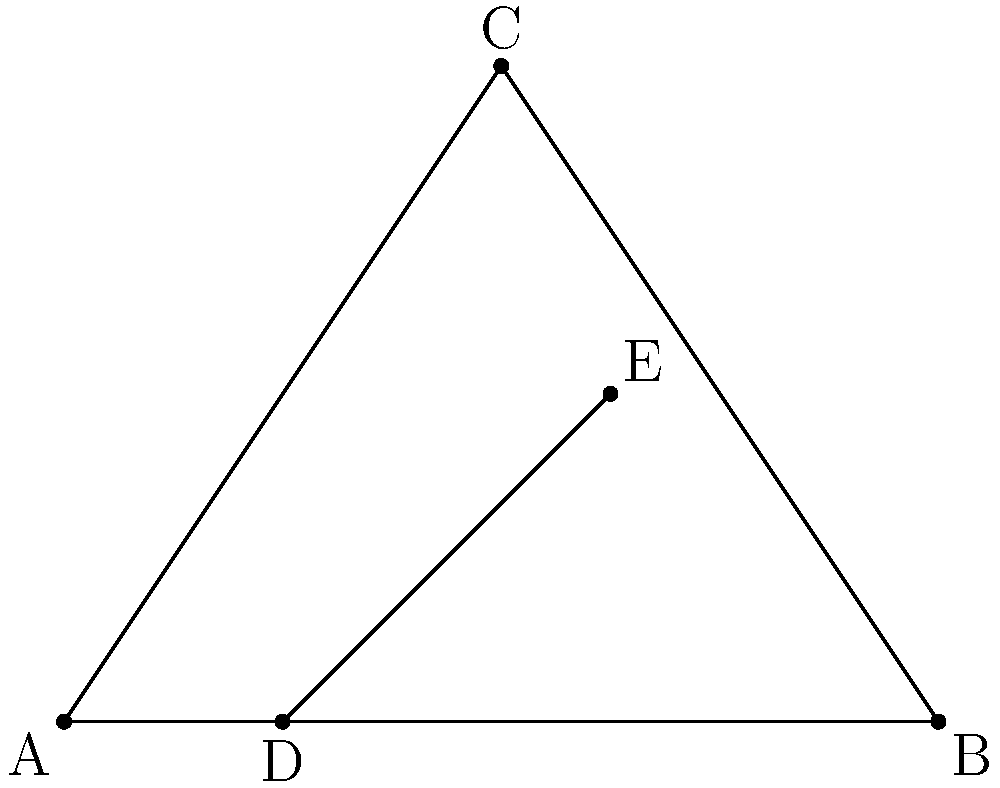In the diagram above, triangle ABC is intersected by line DE, which is parallel to side AB. If AD = 2 cm, DB = 6 cm, and AE = 5 cm, what is the length of EB? To solve this problem, we'll use the properties of similar triangles:

1) Triangle ADE is similar to triangle CEB (due to the parallel line DE).

2) The ratio of corresponding sides in similar triangles is constant. Let's call this ratio r.

3) We can find r using the known lengths:
   $r = \frac{AD}{DB} = \frac{2}{6} = \frac{1}{3}$

4) We can also express r using AE and EB:
   $r = \frac{AE}{AB} = \frac{5}{AB}$

5) Since these ratios are equal:
   $\frac{1}{3} = \frac{5}{AB}$

6) We can find AB:
   $AB = 5 \times 3 = 15$ cm

7) Now we can find EB:
   $EB = AB - AE = 15 - 5 = 10$ cm

Therefore, the length of EB is 10 cm.
Answer: 10 cm 